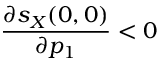<formula> <loc_0><loc_0><loc_500><loc_500>\frac { \partial s _ { X } ( 0 , 0 ) } { \partial p _ { 1 } } < 0</formula> 